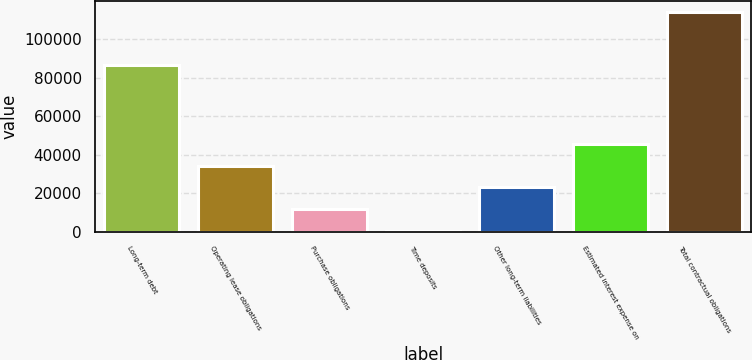Convert chart to OTSL. <chart><loc_0><loc_0><loc_500><loc_500><bar_chart><fcel>Long-term debt<fcel>Operating lease obligations<fcel>Purchase obligations<fcel>Time deposits<fcel>Other long-term liabilities<fcel>Estimated interest expense on<fcel>Total contractual obligations<nl><fcel>86719<fcel>34468.6<fcel>11824.2<fcel>502<fcel>23146.4<fcel>45790.8<fcel>113724<nl></chart> 